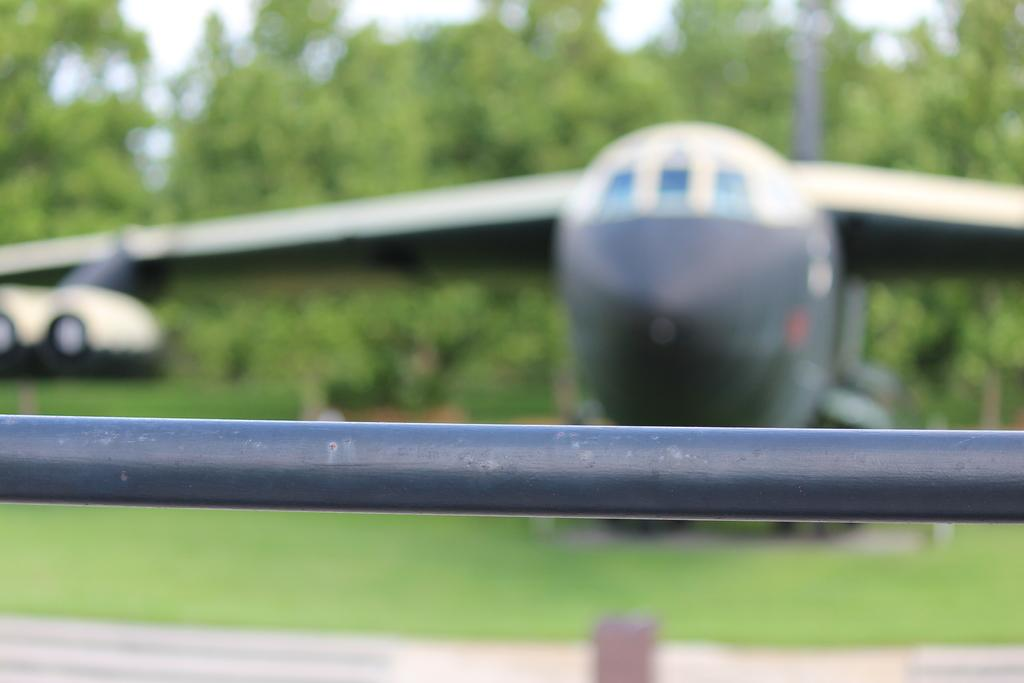What is located at the bottom of the image? There is a road at the bottom of the image. What can be seen in the middle of the image? There is an airplane in the middle of the image. What type of natural scenery is visible in the background of the image? There are trees in the background of the image. What is the opinion of the trees in the background of the image? The trees in the background of the image do not have an opinion, as they are inanimate objects. What does the airplane wish to do in the image? The image does not provide any information about the airplane's wishes or intentions. 